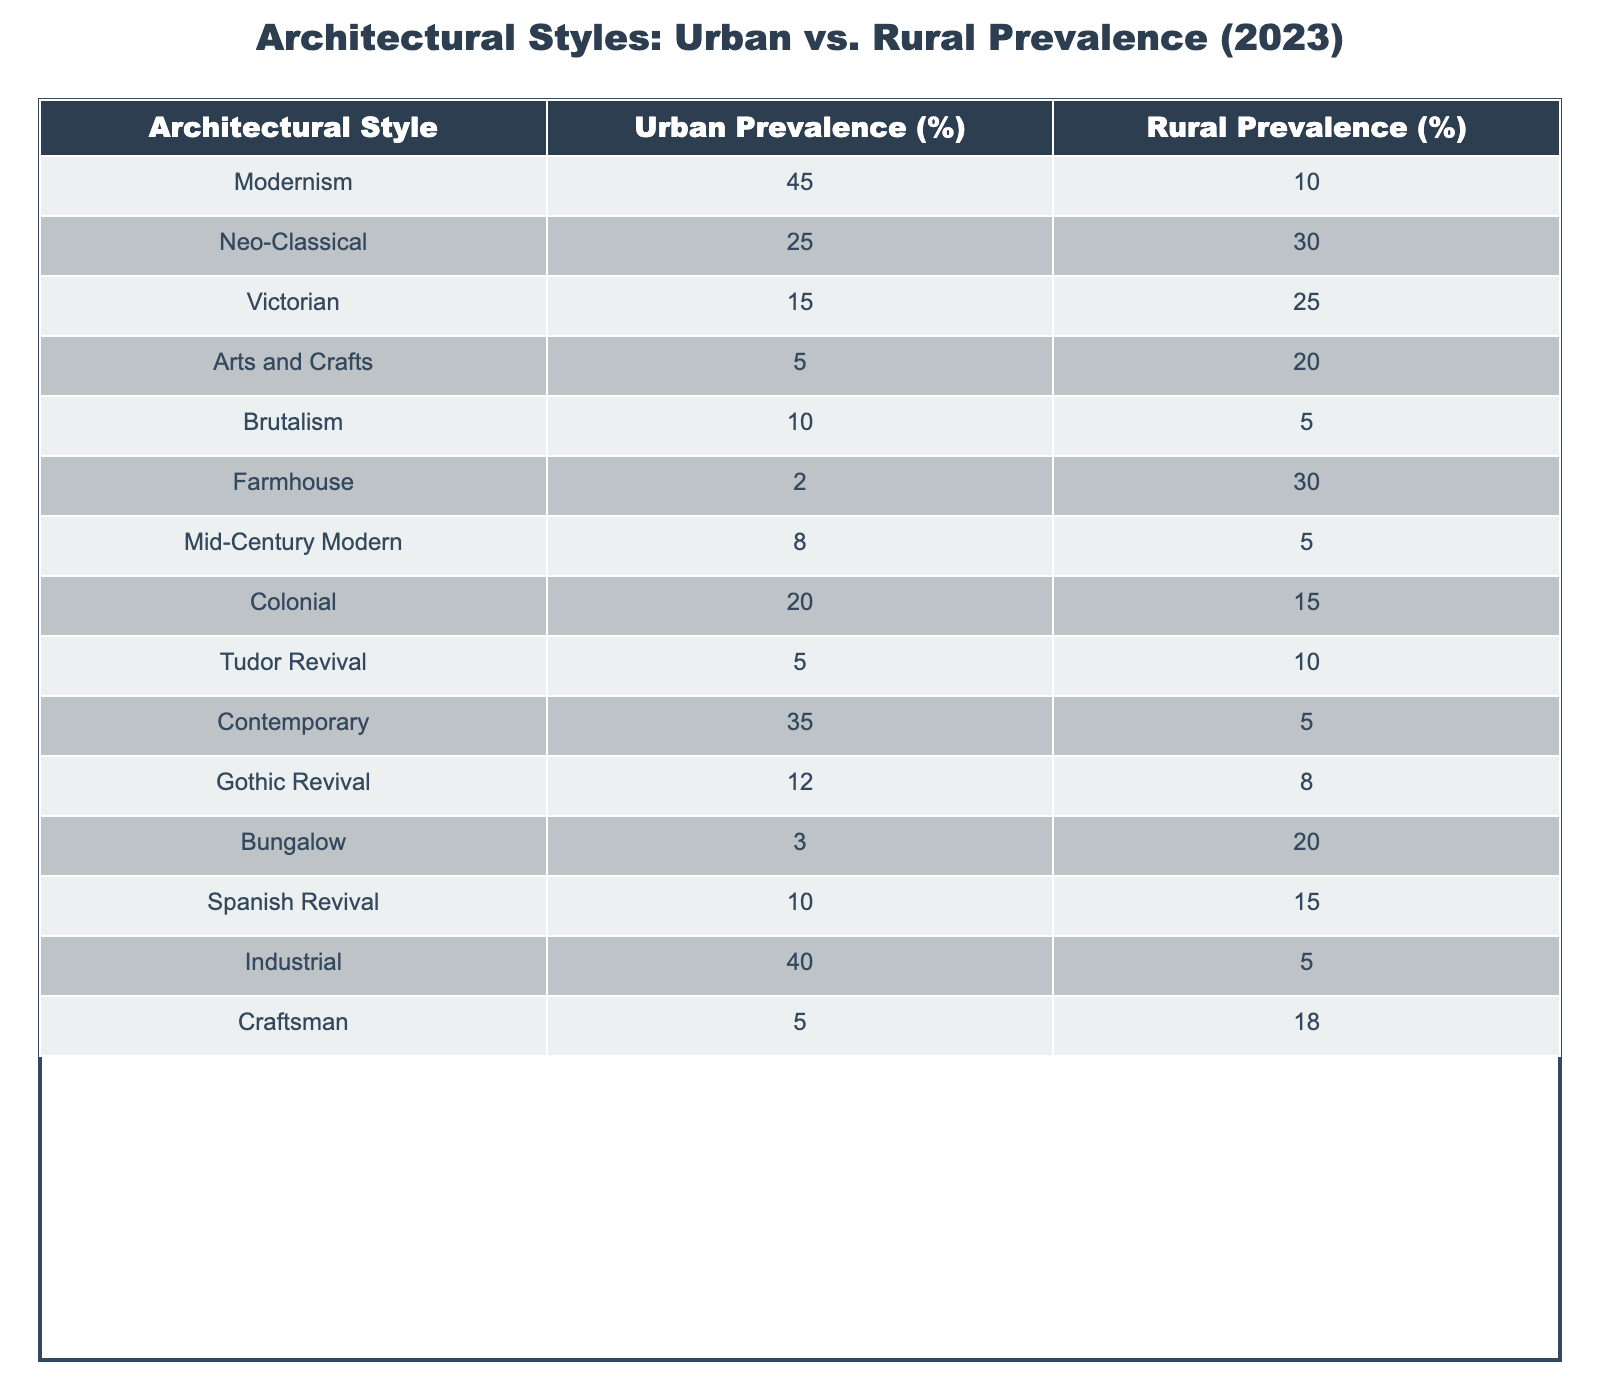What architectural style has the highest urban prevalence in 2023? The table shows that Modernism has an urban prevalence of 45%, which is the highest percentage among all styles listed.
Answer: Modernism What is the rural prevalence of Victorian architecture? According to the table, the rural prevalence of Victorian architecture is 25%.
Answer: 25% What percentage of the urban prevalence do Industrial and Modernism styles have together? Urban prevalence for Industrial is 40% and for Modernism is 45%. Adding them gives: 40 + 45 = 85%.
Answer: 85% Is there a higher prevalence of Farmhouse architecture in urban settings than in rural settings? The table indicates that Farmhouse has an urban prevalence of 2% and a rural prevalence of 30%, so it is not higher in urban settings.
Answer: No What is the difference in prevalence of Neo-Classical architecture between urban and rural settings? Neo-Classical architecture has an urban prevalence of 25% and a rural prevalence of 30%. The difference is calculated as 30 - 25 = 5%.
Answer: 5% What is the average urban prevalence of the following styles: Mid-Century Modern, Bungalow, and Brutalism? The urban prevalence values for the styles are 8% for Mid-Century Modern, 3% for Bungalow, and 10% for Brutalism. Adding these gives: 8 + 3 + 10 = 21%. The average is calculated as 21% / 3 = 7%.
Answer: 7% Which architectural style is least prevalent in urban settings? The table shows that both Farmhouse and Bungalow have the least urban prevalence at 2% and 3% respectively, however, Farmhouse has the lowest at 2%.
Answer: Farmhouse Which architectural styles have higher rural prevalence than urban prevalence? From the table, the styles that have higher rural prevalence than urban prevalence are Neo-Classical, Victorian, Arts and Crafts, Farmhouse, and Bungalow.
Answer: Neo-Classical, Victorian, Arts and Crafts, Farmhouse, Bungalow What is the total urban prevalence of all styles listed? Adding the urban prevalences of all styles yields: 45 + 25 + 15 + 5 + 10 + 2 + 8 + 20 + 5 + 35 + 12 + 3 + 10 + 40 + 5 = 315%.
Answer: 315% If we consider only styles with rural prevalence above 20%, what is their combined urban prevalence? The styles that meet this criterion are Neo-Classical (25%), Victorian (15%), Arts and Crafts (5%), Farmhouse (2%), and Bungalow (3%). Their urban prevalence combined is 25 + 15 + 5 + 2 + 3 = 50%.
Answer: 50% 